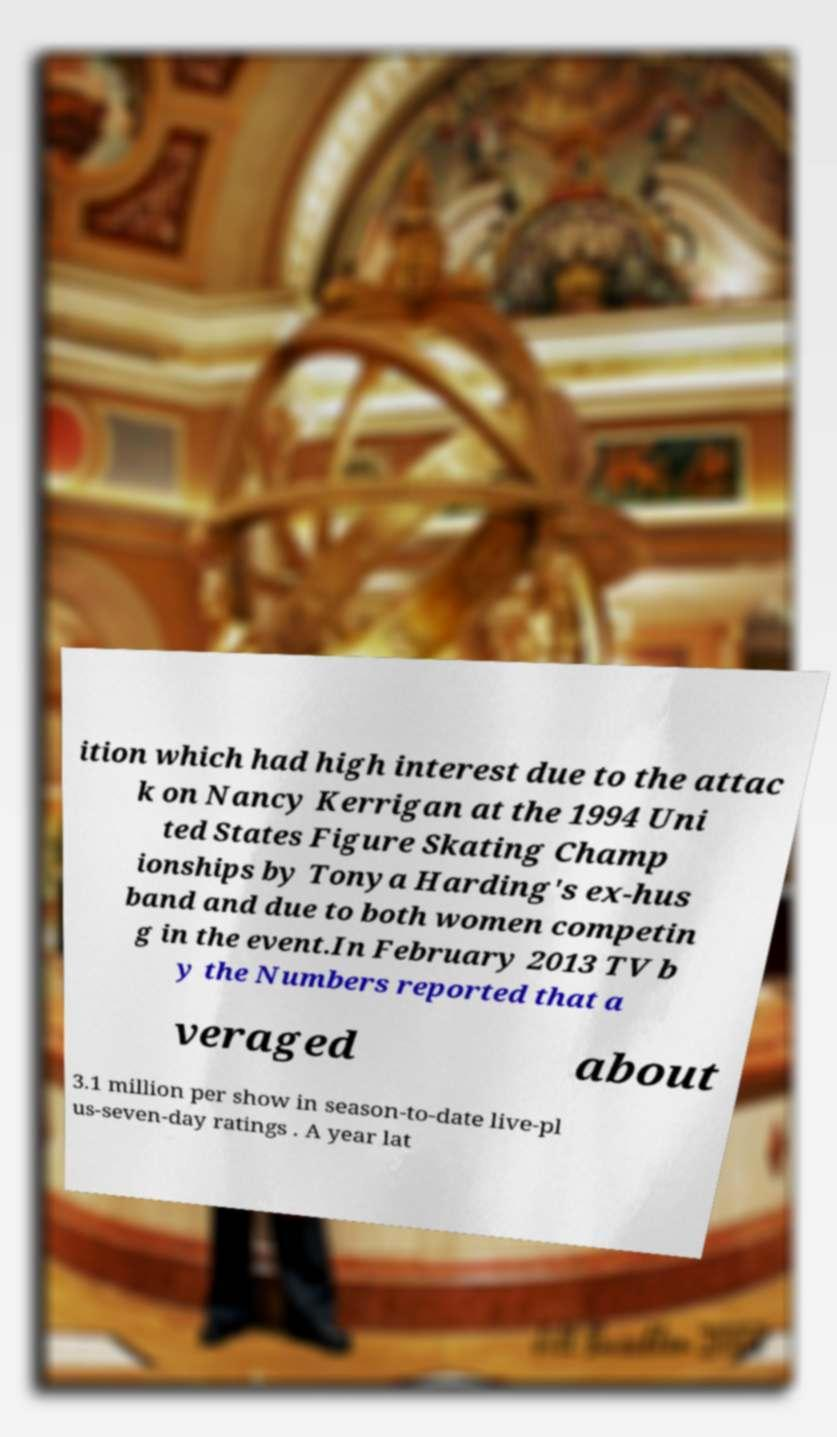For documentation purposes, I need the text within this image transcribed. Could you provide that? ition which had high interest due to the attac k on Nancy Kerrigan at the 1994 Uni ted States Figure Skating Champ ionships by Tonya Harding's ex-hus band and due to both women competin g in the event.In February 2013 TV b y the Numbers reported that a veraged about 3.1 million per show in season-to-date live-pl us-seven-day ratings . A year lat 